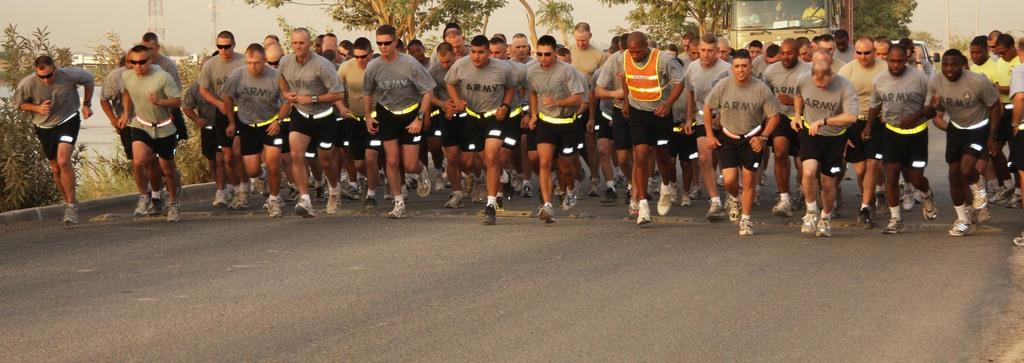What are the people in the image doing? The people in the image are running on the road. What can be seen in the background of the image? There are trees, buildings, poles, towers, and a vehicle in the background. How many types of structures are visible in the background? There are at least four types of structures visible in the background: buildings, poles, towers, and a vehicle. Can you see any bees buzzing around the people running in the image? There are no bees visible in the image; it features people running on the road with various structures in the background. 